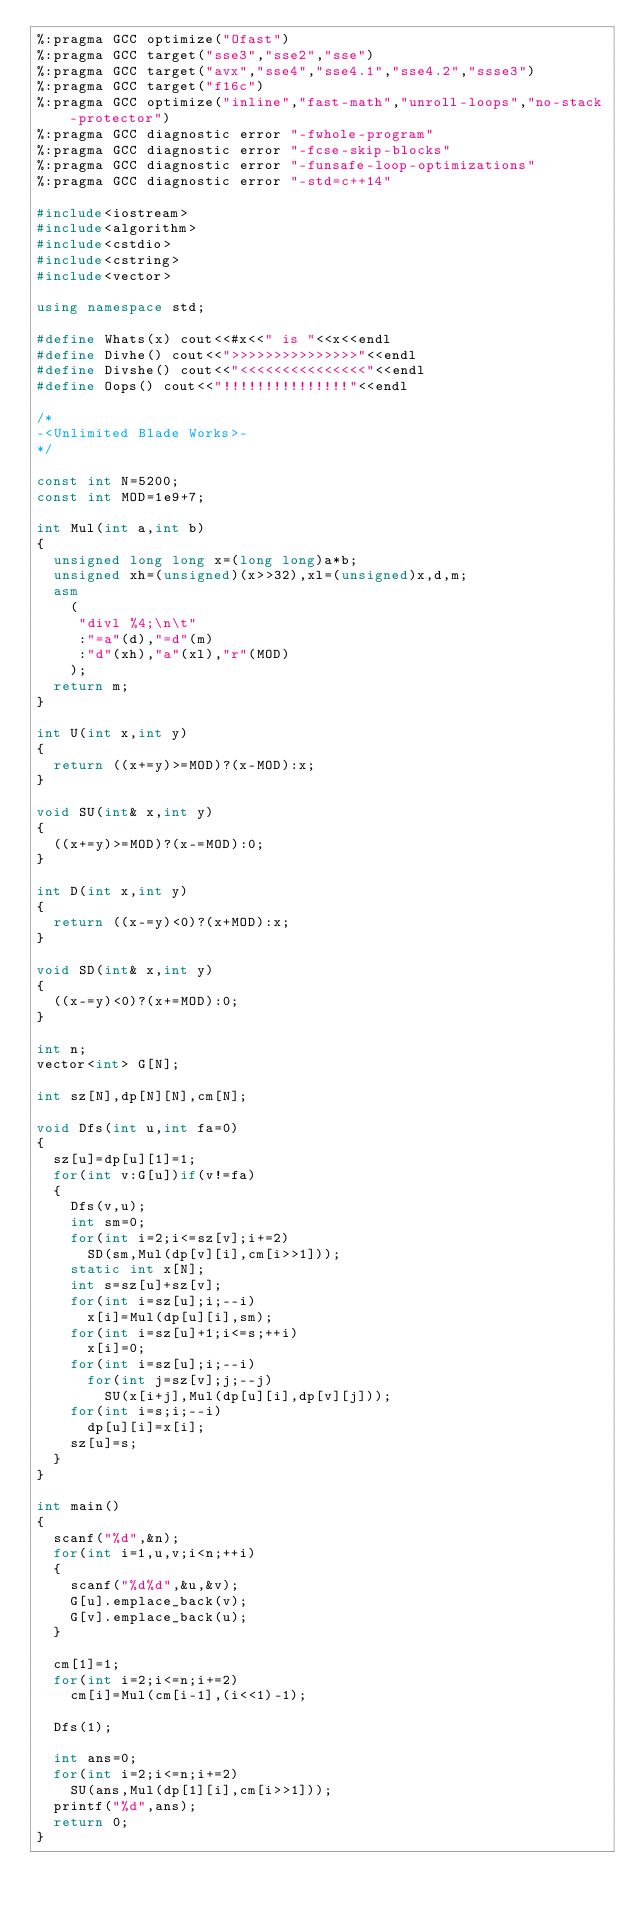<code> <loc_0><loc_0><loc_500><loc_500><_C++_>%:pragma GCC optimize("Ofast")
%:pragma GCC target("sse3","sse2","sse")
%:pragma GCC target("avx","sse4","sse4.1","sse4.2","ssse3")
%:pragma GCC target("f16c")
%:pragma GCC optimize("inline","fast-math","unroll-loops","no-stack-protector")
%:pragma GCC diagnostic error "-fwhole-program"
%:pragma GCC diagnostic error "-fcse-skip-blocks"
%:pragma GCC diagnostic error "-funsafe-loop-optimizations"
%:pragma GCC diagnostic error "-std=c++14"

#include<iostream>
#include<algorithm>
#include<cstdio>
#include<cstring>
#include<vector>

using namespace std;

#define Whats(x) cout<<#x<<" is "<<x<<endl
#define Divhe() cout<<">>>>>>>>>>>>>>>"<<endl
#define Divshe() cout<<"<<<<<<<<<<<<<<<"<<endl
#define Oops() cout<<"!!!!!!!!!!!!!!!"<<endl

/*
-<Unlimited Blade Works>-
*/

const int N=5200;
const int MOD=1e9+7;

int Mul(int a,int b)
{
	unsigned long long x=(long long)a*b;
	unsigned xh=(unsigned)(x>>32),xl=(unsigned)x,d,m;
	asm
		(
		 "divl %4;\n\t"
		 :"=a"(d),"=d"(m)
		 :"d"(xh),"a"(xl),"r"(MOD)
		);
	return m;
}

int U(int x,int y)
{
	return ((x+=y)>=MOD)?(x-MOD):x;
}

void SU(int& x,int y)
{
	((x+=y)>=MOD)?(x-=MOD):0;
}

int D(int x,int y)
{
	return ((x-=y)<0)?(x+MOD):x;
}

void SD(int& x,int y)
{
	((x-=y)<0)?(x+=MOD):0;
}

int n;
vector<int> G[N];

int sz[N],dp[N][N],cm[N];

void Dfs(int u,int fa=0)
{
	sz[u]=dp[u][1]=1;
	for(int v:G[u])if(v!=fa)
	{
		Dfs(v,u);
		int sm=0;
		for(int i=2;i<=sz[v];i+=2)
			SD(sm,Mul(dp[v][i],cm[i>>1]));
		static int x[N];
		int s=sz[u]+sz[v];
		for(int i=sz[u];i;--i)
			x[i]=Mul(dp[u][i],sm);
		for(int i=sz[u]+1;i<=s;++i)
			x[i]=0;
		for(int i=sz[u];i;--i)
			for(int j=sz[v];j;--j)
				SU(x[i+j],Mul(dp[u][i],dp[v][j]));
		for(int i=s;i;--i)
			dp[u][i]=x[i];
		sz[u]=s;
	}
}

int main()
{
	scanf("%d",&n);
	for(int i=1,u,v;i<n;++i)
	{
		scanf("%d%d",&u,&v);
		G[u].emplace_back(v);
		G[v].emplace_back(u);
	}

	cm[1]=1;
	for(int i=2;i<=n;i+=2)
		cm[i]=Mul(cm[i-1],(i<<1)-1);

	Dfs(1);

	int ans=0;
	for(int i=2;i<=n;i+=2)
		SU(ans,Mul(dp[1][i],cm[i>>1]));
	printf("%d",ans);
	return 0;
}
</code> 